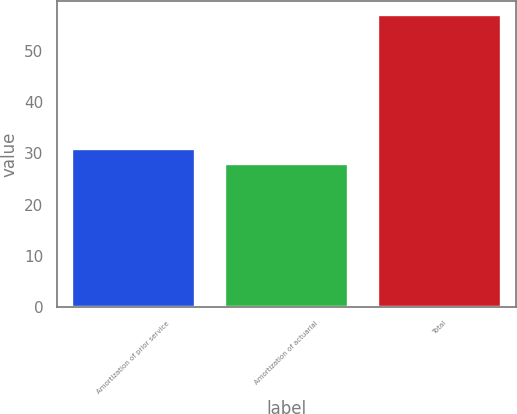Convert chart to OTSL. <chart><loc_0><loc_0><loc_500><loc_500><bar_chart><fcel>Amortization of prior service<fcel>Amortization of actuarial<fcel>Total<nl><fcel>30.9<fcel>28<fcel>57<nl></chart> 